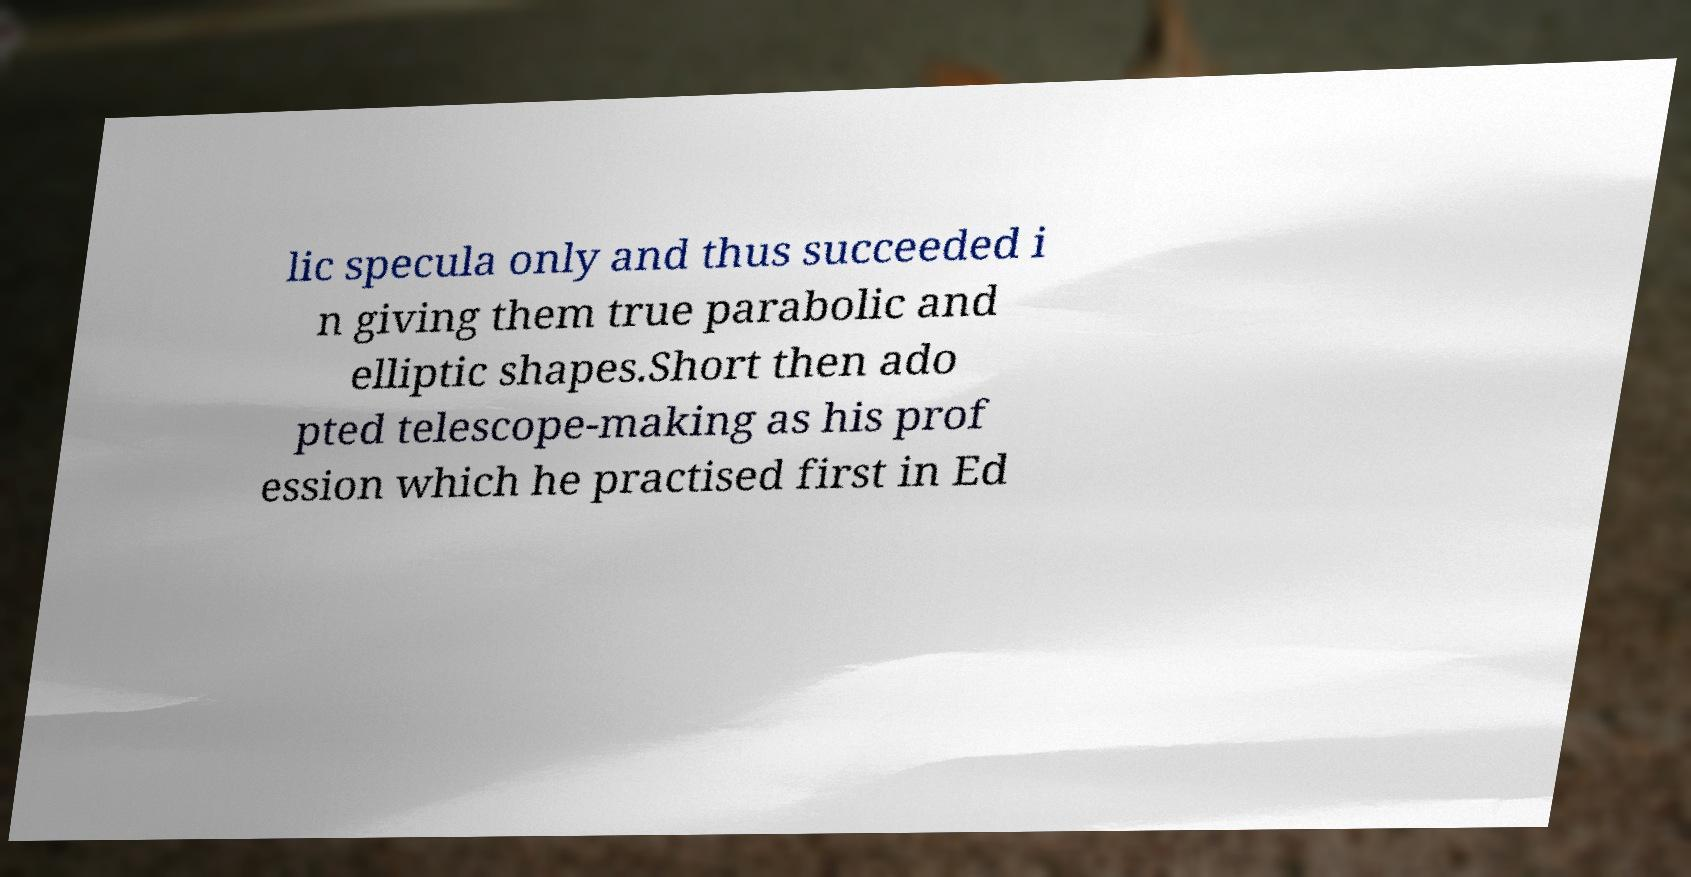What messages or text are displayed in this image? I need them in a readable, typed format. lic specula only and thus succeeded i n giving them true parabolic and elliptic shapes.Short then ado pted telescope-making as his prof ession which he practised first in Ed 